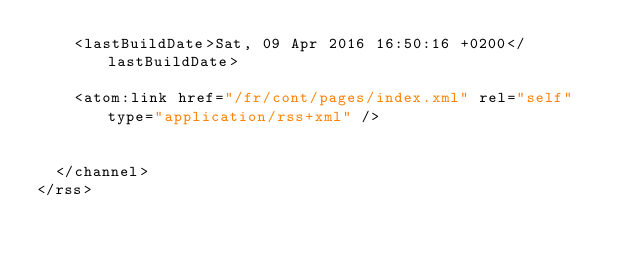<code> <loc_0><loc_0><loc_500><loc_500><_XML_>    <lastBuildDate>Sat, 09 Apr 2016 16:50:16 +0200</lastBuildDate>
    
	<atom:link href="/fr/cont/pages/index.xml" rel="self" type="application/rss+xml" />
    
    
  </channel>
</rss></code> 